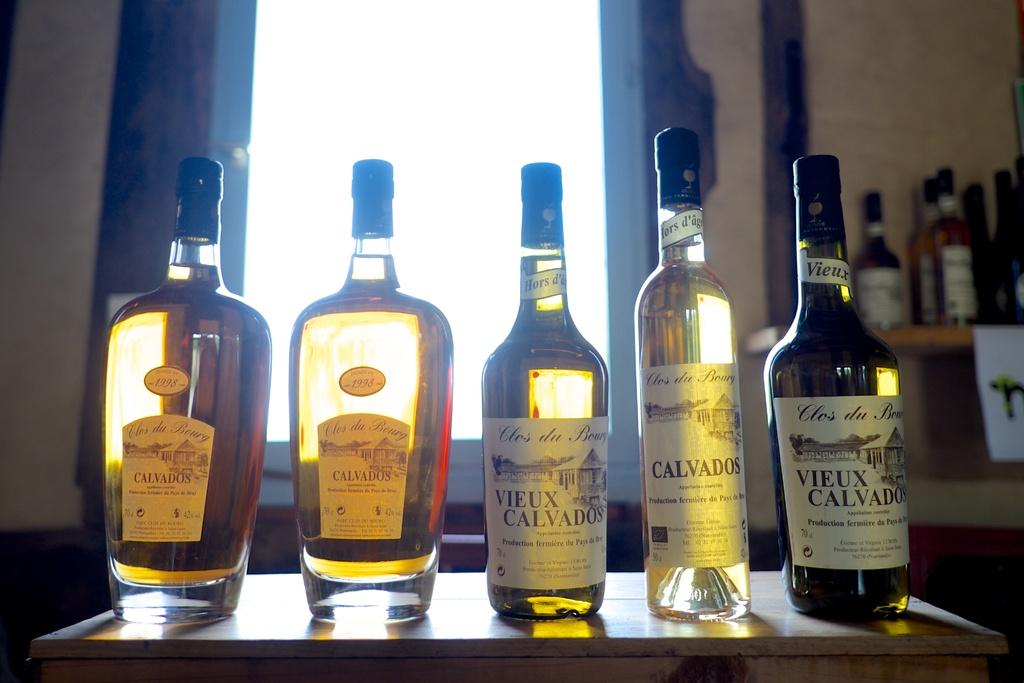What is in the bottle on the right?
Make the answer very short. Vieux calvado. 